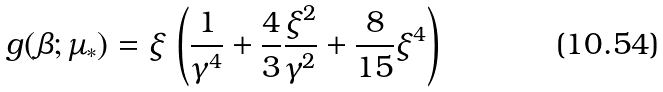<formula> <loc_0><loc_0><loc_500><loc_500>g ( \beta ; \mu _ { * } ) = \xi \, \left ( \frac { 1 } { \gamma ^ { 4 } } + \frac { 4 } { 3 } \frac { \xi ^ { 2 } } { \gamma ^ { 2 } } + \frac { 8 } { 1 5 } \xi ^ { 4 } \right )</formula> 